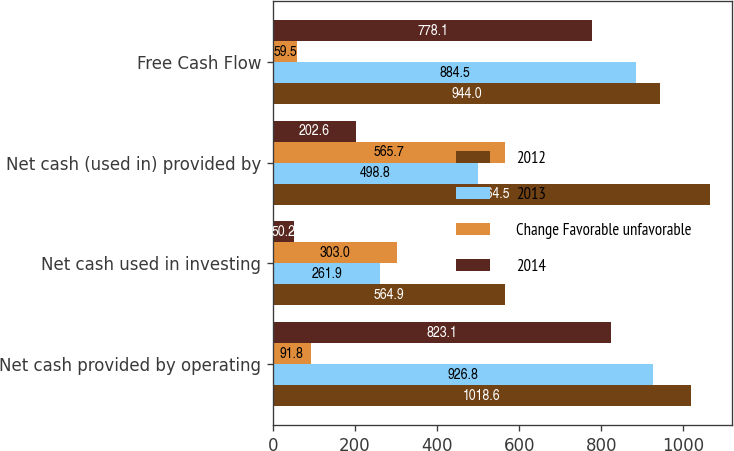Convert chart. <chart><loc_0><loc_0><loc_500><loc_500><stacked_bar_chart><ecel><fcel>Net cash provided by operating<fcel>Net cash used in investing<fcel>Net cash (used in) provided by<fcel>Free Cash Flow<nl><fcel>2012<fcel>1018.6<fcel>564.9<fcel>1064.5<fcel>944<nl><fcel>2013<fcel>926.8<fcel>261.9<fcel>498.8<fcel>884.5<nl><fcel>Change Favorable unfavorable<fcel>91.8<fcel>303<fcel>565.7<fcel>59.5<nl><fcel>2014<fcel>823.1<fcel>50.2<fcel>202.6<fcel>778.1<nl></chart> 